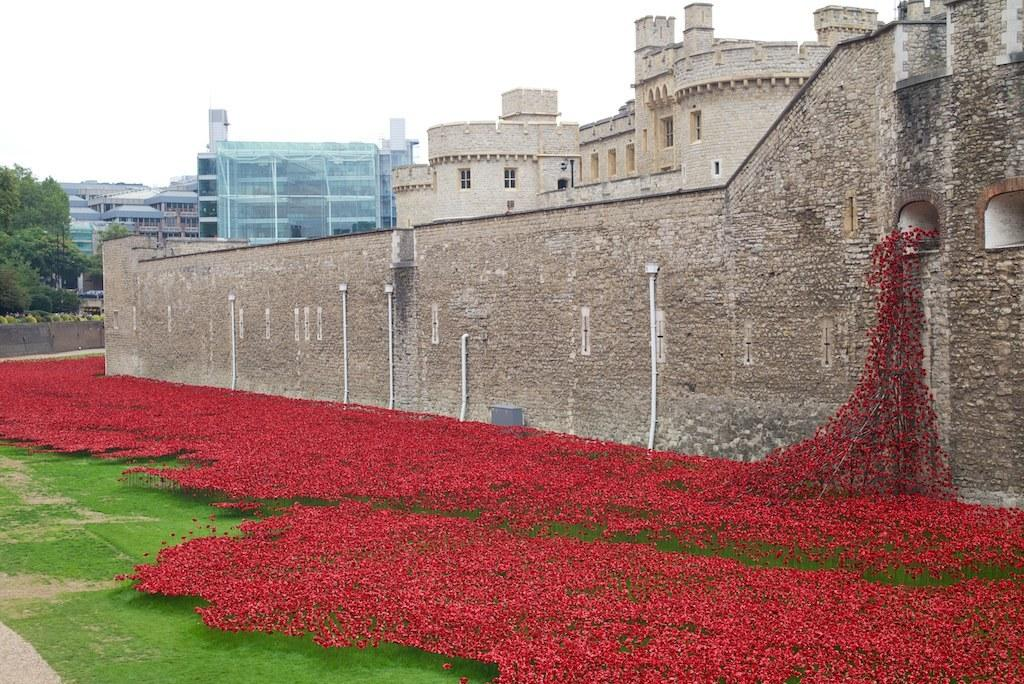What type of vegetation is in the front of the image? There are flowers in the front of the image. What type of structures can be seen in the background of the image? There are buildings in the background of the image. What type of vegetation is on the left side of the image? There are trees on the left side of the image. What type of rhythm can be heard coming from the flowers in the image? There is no rhythm present in the image, as flowers do not produce sound. What type of achiever is standing next to the trees on the left side of the image? There is no achiever present in the image; it only features flowers, buildings, and trees. 